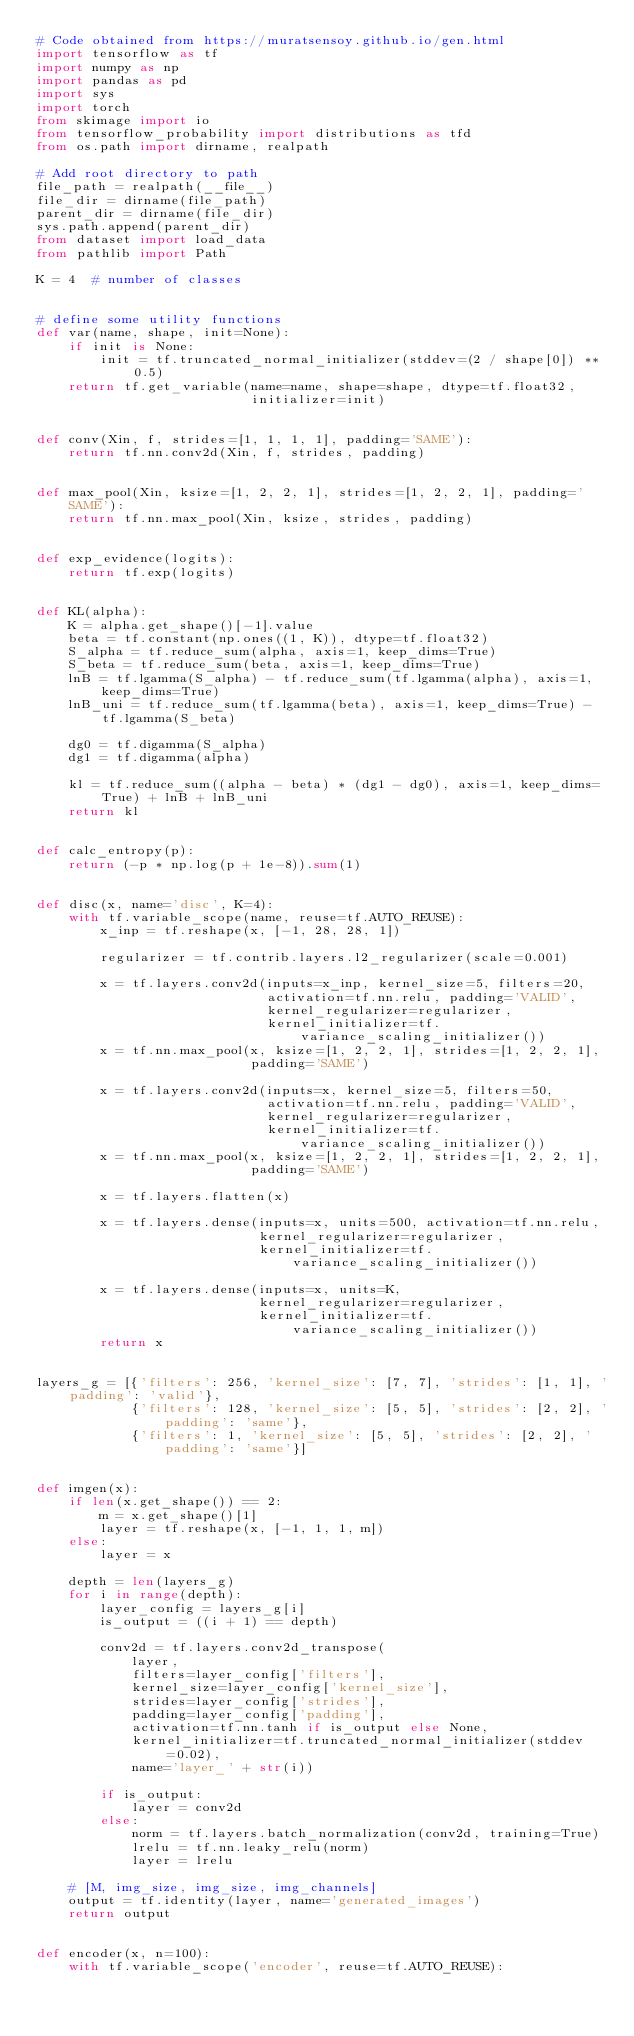Convert code to text. <code><loc_0><loc_0><loc_500><loc_500><_Python_># Code obtained from https://muratsensoy.github.io/gen.html
import tensorflow as tf
import numpy as np
import pandas as pd
import sys
import torch
from skimage import io
from tensorflow_probability import distributions as tfd
from os.path import dirname, realpath

# Add root directory to path
file_path = realpath(__file__)
file_dir = dirname(file_path)
parent_dir = dirname(file_dir)
sys.path.append(parent_dir)
from dataset import load_data
from pathlib import Path

K = 4  # number of classes


# define some utility functions
def var(name, shape, init=None):
    if init is None:
        init = tf.truncated_normal_initializer(stddev=(2 / shape[0]) ** 0.5)
    return tf.get_variable(name=name, shape=shape, dtype=tf.float32,
                           initializer=init)


def conv(Xin, f, strides=[1, 1, 1, 1], padding='SAME'):
    return tf.nn.conv2d(Xin, f, strides, padding)


def max_pool(Xin, ksize=[1, 2, 2, 1], strides=[1, 2, 2, 1], padding='SAME'):
    return tf.nn.max_pool(Xin, ksize, strides, padding)


def exp_evidence(logits):
    return tf.exp(logits)


def KL(alpha):
    K = alpha.get_shape()[-1].value
    beta = tf.constant(np.ones((1, K)), dtype=tf.float32)
    S_alpha = tf.reduce_sum(alpha, axis=1, keep_dims=True)
    S_beta = tf.reduce_sum(beta, axis=1, keep_dims=True)
    lnB = tf.lgamma(S_alpha) - tf.reduce_sum(tf.lgamma(alpha), axis=1, keep_dims=True)
    lnB_uni = tf.reduce_sum(tf.lgamma(beta), axis=1, keep_dims=True) - tf.lgamma(S_beta)

    dg0 = tf.digamma(S_alpha)
    dg1 = tf.digamma(alpha)

    kl = tf.reduce_sum((alpha - beta) * (dg1 - dg0), axis=1, keep_dims=True) + lnB + lnB_uni
    return kl


def calc_entropy(p):
    return (-p * np.log(p + 1e-8)).sum(1)


def disc(x, name='disc', K=4):
    with tf.variable_scope(name, reuse=tf.AUTO_REUSE):
        x_inp = tf.reshape(x, [-1, 28, 28, 1])

        regularizer = tf.contrib.layers.l2_regularizer(scale=0.001)

        x = tf.layers.conv2d(inputs=x_inp, kernel_size=5, filters=20,
                             activation=tf.nn.relu, padding='VALID',
                             kernel_regularizer=regularizer,
                             kernel_initializer=tf.variance_scaling_initializer())
        x = tf.nn.max_pool(x, ksize=[1, 2, 2, 1], strides=[1, 2, 2, 1],
                           padding='SAME')

        x = tf.layers.conv2d(inputs=x, kernel_size=5, filters=50,
                             activation=tf.nn.relu, padding='VALID',
                             kernel_regularizer=regularizer,
                             kernel_initializer=tf.variance_scaling_initializer())
        x = tf.nn.max_pool(x, ksize=[1, 2, 2, 1], strides=[1, 2, 2, 1],
                           padding='SAME')

        x = tf.layers.flatten(x)

        x = tf.layers.dense(inputs=x, units=500, activation=tf.nn.relu,
                            kernel_regularizer=regularizer,
                            kernel_initializer=tf.variance_scaling_initializer())

        x = tf.layers.dense(inputs=x, units=K,
                            kernel_regularizer=regularizer,
                            kernel_initializer=tf.variance_scaling_initializer())
        return x


layers_g = [{'filters': 256, 'kernel_size': [7, 7], 'strides': [1, 1], 'padding': 'valid'},
            {'filters': 128, 'kernel_size': [5, 5], 'strides': [2, 2], 'padding': 'same'},
            {'filters': 1, 'kernel_size': [5, 5], 'strides': [2, 2], 'padding': 'same'}]


def imgen(x):
    if len(x.get_shape()) == 2:
        m = x.get_shape()[1]
        layer = tf.reshape(x, [-1, 1, 1, m])
    else:
        layer = x

    depth = len(layers_g)
    for i in range(depth):
        layer_config = layers_g[i]
        is_output = ((i + 1) == depth)

        conv2d = tf.layers.conv2d_transpose(
            layer,
            filters=layer_config['filters'],
            kernel_size=layer_config['kernel_size'],
            strides=layer_config['strides'],
            padding=layer_config['padding'],
            activation=tf.nn.tanh if is_output else None,
            kernel_initializer=tf.truncated_normal_initializer(stddev=0.02),
            name='layer_' + str(i))

        if is_output:
            layer = conv2d
        else:
            norm = tf.layers.batch_normalization(conv2d, training=True)
            lrelu = tf.nn.leaky_relu(norm)
            layer = lrelu

    # [M, img_size, img_size, img_channels]
    output = tf.identity(layer, name='generated_images')
    return output


def encoder(x, n=100):
    with tf.variable_scope('encoder', reuse=tf.AUTO_REUSE):</code> 